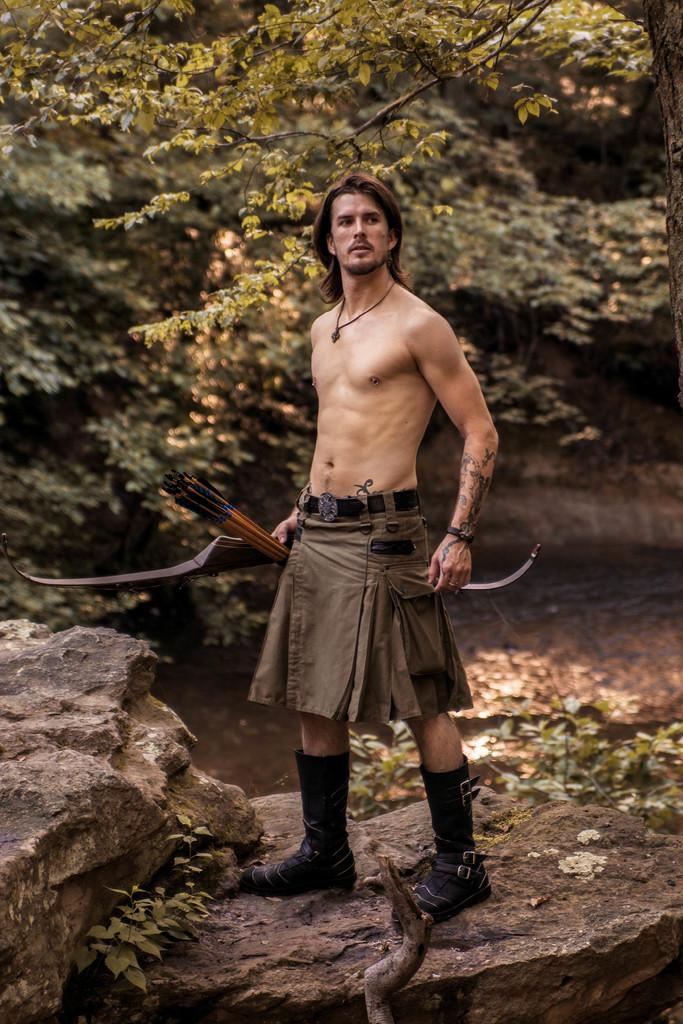What is the man doing in the image? The man is standing on a rock in the image. What can be seen in the background of the image? There are trees and water visible in the image. What type of pies is the man holding in the image? There are no pies present in the image; the man is standing on a rock with trees and water visible in the background. 